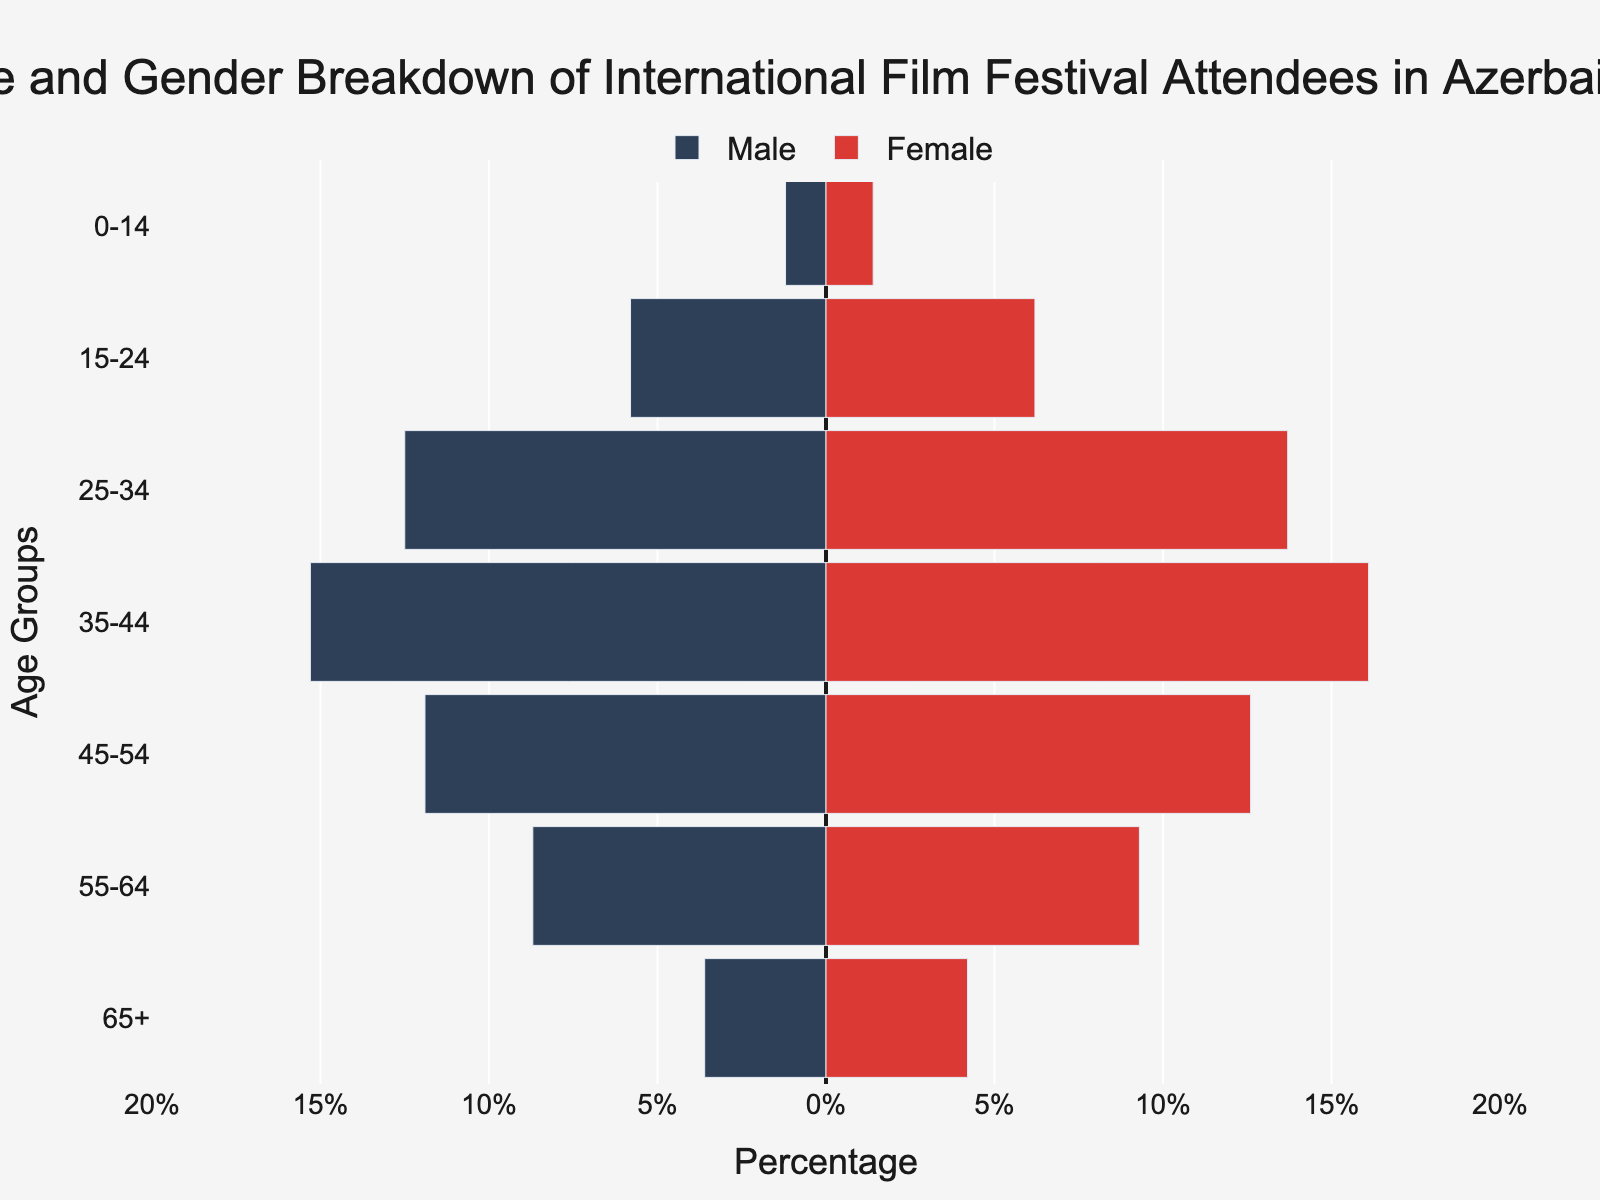What's the title of the figure? The title is positioned at the top center of the figure. It's a brief description of what the figure represents.
Answer: Age and Gender Breakdown of International Film Festival Attendees in Azerbaijan What is the percentage of male attendees in the 25-34 age group? Locate the bar corresponding to the 25-34 age group on the left side of the graph (blue), note the length of this bar, and refer to the x-axis labels for the percentage value.
Answer: 12.5% Which gender has a higher percentage of attendees in the 35-44 age group? Compare the lengths of the bars for the female (red) and male (blue) segments in the 35-44 age group. The bar that extends further represents the higher percentage.
Answer: Female What is the difference in attendance percentage between males and females in the 45-54 age group? Identify the bar lengths for both males and females in the 45-54 age group, then subtract the male percentage from the female percentage to find the difference.
Answer: 0.7% How many age groups have more female attendees than male attendees? Count the instances where the red bar (female) extends further than the blue bar (male) across all age groups.
Answer: 7 Which age group has the smallest gender gap in attendance percentages? Inspect each pair of bars (male and female) and calculate the difference in their lengths. The smallest difference indicates the age group with the smallest gender gap.
Answer: 55-64 What is the combined percentage of male attendees in the 15-24 and 25-34 age groups? Sum the percentages of male attendees in both the 15-24 and 25-34 age groups. Add the values from the bars in these age segments to get the total percentage.
Answer: 18.3% Which age group has the highest percentage of attendees overall? Combine the male and female percentages for each age group and compare the totals. The age group with the highest combined value is the answer.
Answer: 35-44 Is the attendance percentage of females in the 65+ age group greater than that of males in the 55-64 age group? Compare the length of the red bar in the 65+ age group with the length of the blue bar in the 55-64 age group.
Answer: No 